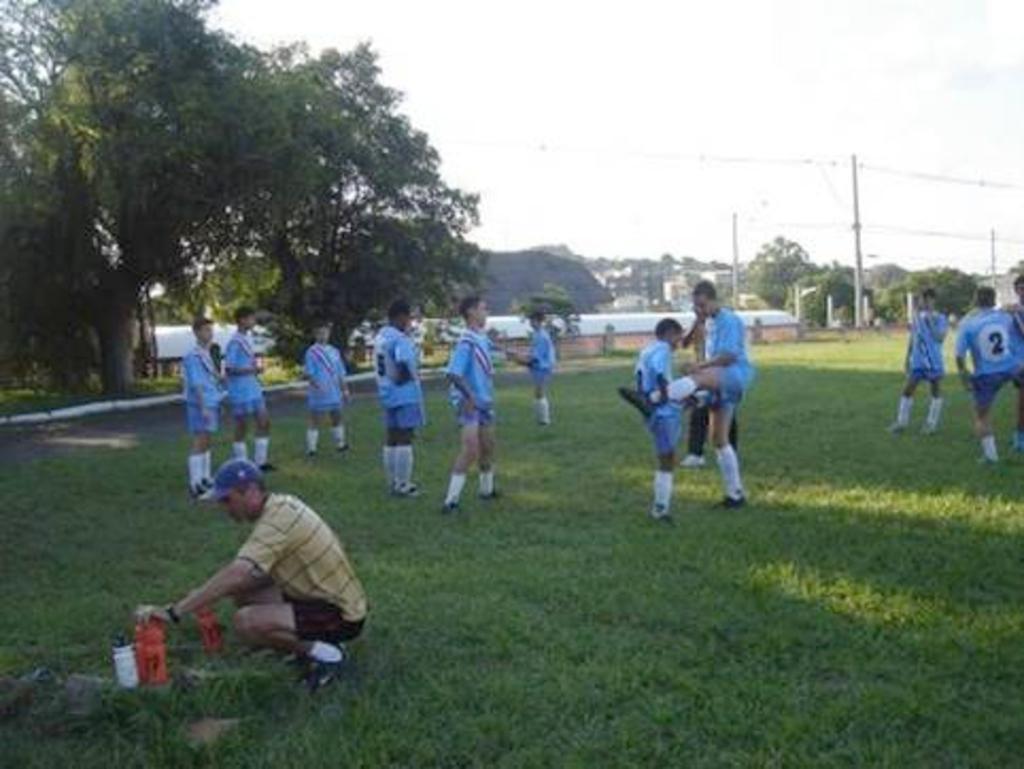Describe this image in one or two sentences. In the image in the center we can see few people were standing and they were in blue color t shirt. On the left side of the image we can see one person holding bottle and he is wearing cap. In the background we can see sky,clouds,poles,wires,buildings,trees,fence and grass. 